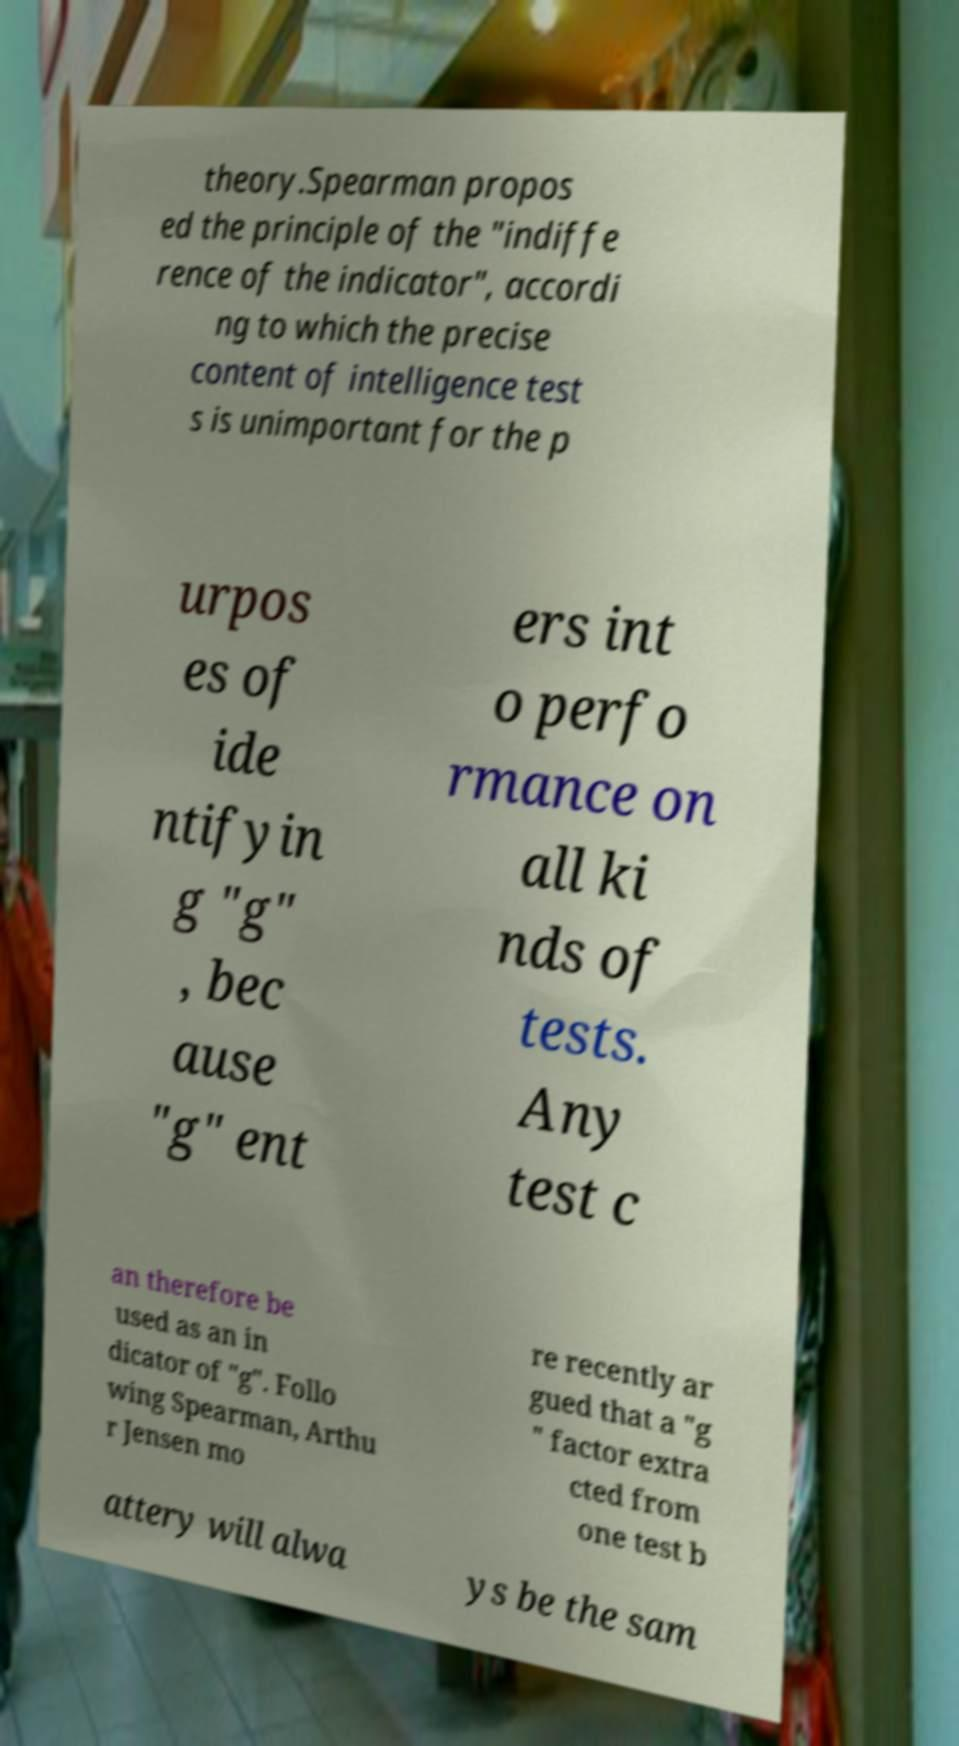Please identify and transcribe the text found in this image. theory.Spearman propos ed the principle of the "indiffe rence of the indicator", accordi ng to which the precise content of intelligence test s is unimportant for the p urpos es of ide ntifyin g "g" , bec ause "g" ent ers int o perfo rmance on all ki nds of tests. Any test c an therefore be used as an in dicator of "g". Follo wing Spearman, Arthu r Jensen mo re recently ar gued that a "g " factor extra cted from one test b attery will alwa ys be the sam 